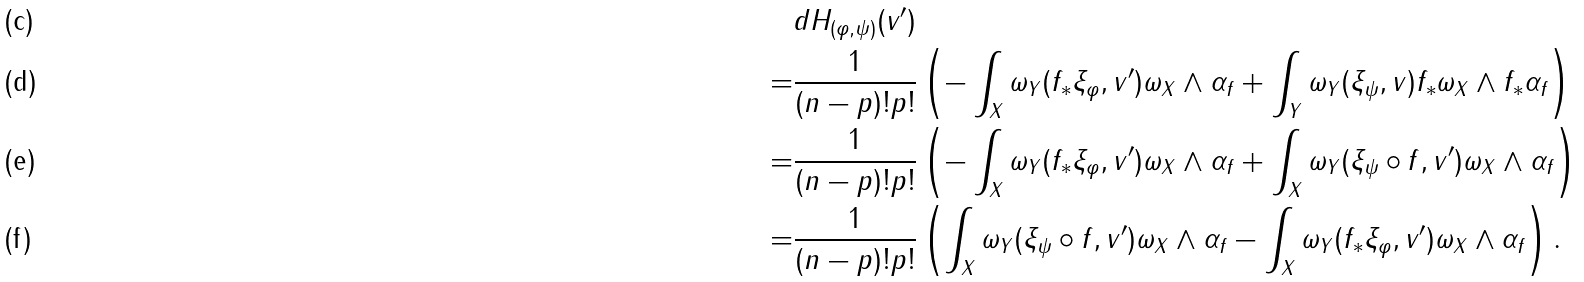Convert formula to latex. <formula><loc_0><loc_0><loc_500><loc_500>& d H _ { ( \varphi , \psi ) } ( v ^ { \prime } ) \\ = & \frac { 1 } { ( n - p ) ! p ! } \left ( - \int _ { X } \omega _ { Y } ( f _ { * } \xi _ { \varphi } , v ^ { \prime } ) \omega _ { X } \wedge \alpha _ { f } + \int _ { Y } \omega _ { Y } ( \xi _ { \psi } , v ) f _ { * } \omega _ { X } \wedge f _ { * } \alpha _ { f } \right ) \\ = & \frac { 1 } { ( n - p ) ! p ! } \left ( - \int _ { X } \omega _ { Y } ( f _ { * } \xi _ { \varphi } , v ^ { \prime } ) \omega _ { X } \wedge \alpha _ { f } + \int _ { X } \omega _ { Y } ( \xi _ { \psi } \circ f , v ^ { \prime } ) \omega _ { X } \wedge \alpha _ { f } \right ) \\ = & \frac { 1 } { ( n - p ) ! p ! } \left ( \int _ { X } \omega _ { Y } ( \xi _ { \psi } \circ f , v ^ { \prime } ) \omega _ { X } \wedge \alpha _ { f } - \int _ { X } \omega _ { Y } ( f _ { * } \xi _ { \varphi } , v ^ { \prime } ) \omega _ { X } \wedge \alpha _ { f } \right ) .</formula> 